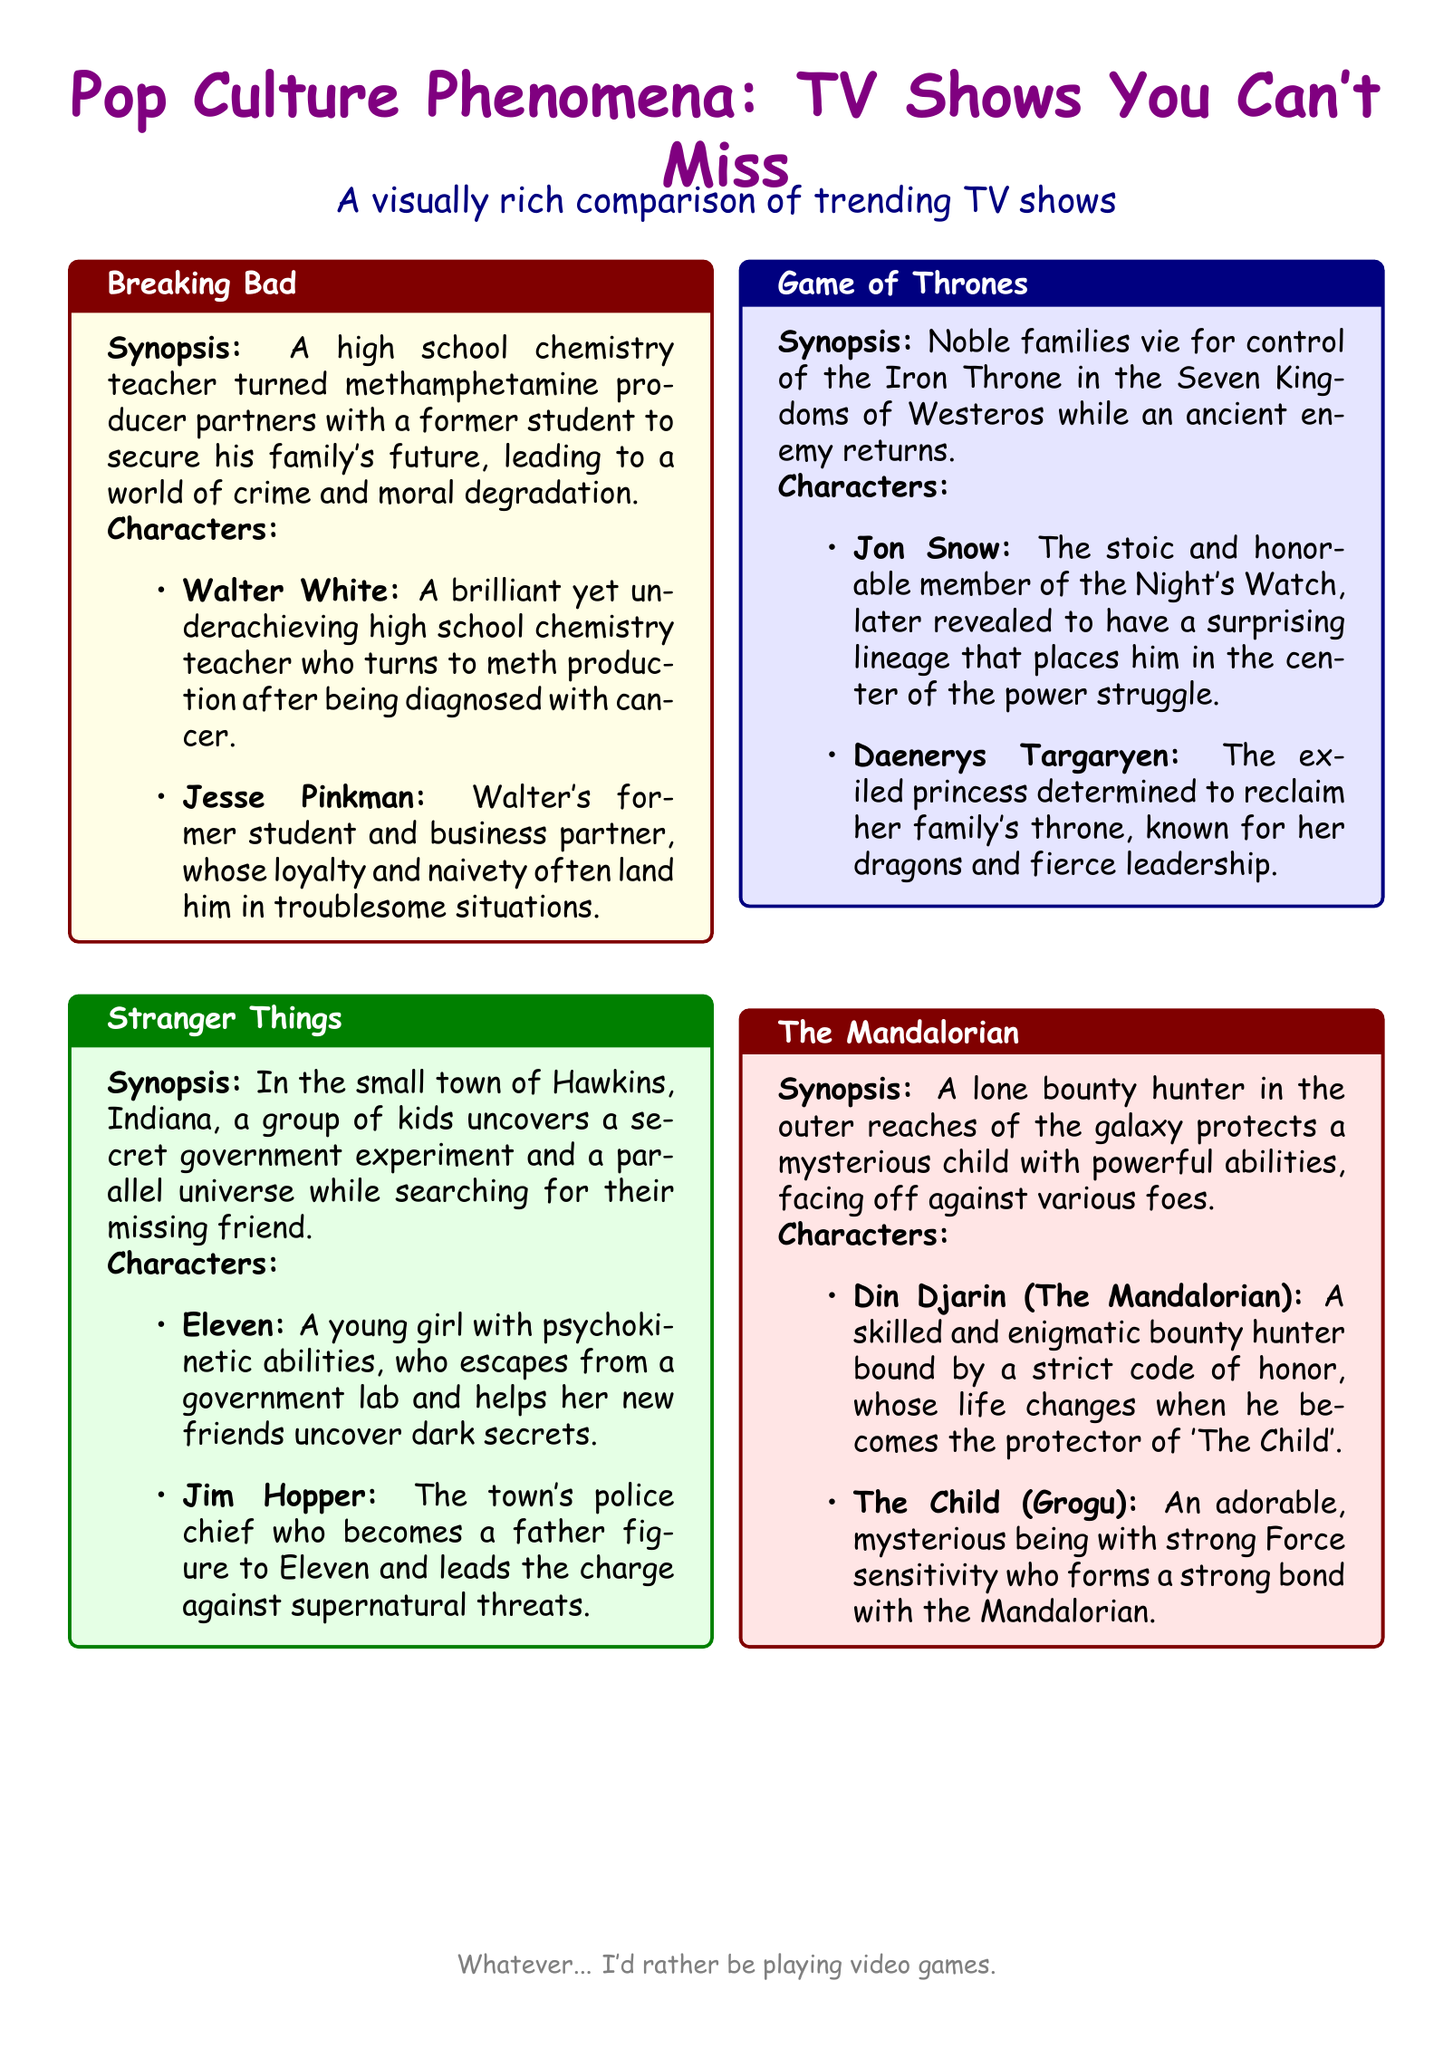what is the title of the document? The title is prominently displayed at the top of the document, highlighting the main theme.
Answer: Pop Culture Phenomena: TV Shows You Can't Miss who is the main character in Breaking Bad? The document provides a detailed character analysis for each TV show, listing key characters.
Answer: Walter White what is the setting for Stranger Things? The document mentions the location where the story of Stranger Things unfolds in its synopsis.
Answer: Hawkins, Indiana which show features a character named Jon Snow? This information is found in the character analysis section of the Game of Thrones synopsis.
Answer: Game of Thrones how many TV shows are compared in the document? The document lists four TV shows within the structured content.
Answer: Four what type of character is Din Djarin in The Mandalorian? This detail is found in the character description under The Mandalorian section in the document.
Answer: Bounty hunter what binds Din Djarin to 'The Child'? The synopsis highlights his role as a protector, indicating a significant connection to the child.
Answer: Protector what is Eleven's unique ability? The character analysis section mentions her special abilities directly.
Answer: Psychokinetic abilities what color is the title box for The Mandalorian? The document specifies the colors for each title box, providing a visual cue of the design.
Answer: Red what emotion is expressed at the bottom of the document? The last line conveys the sentiment of boredom in a humorous way.
Answer: Boredom 